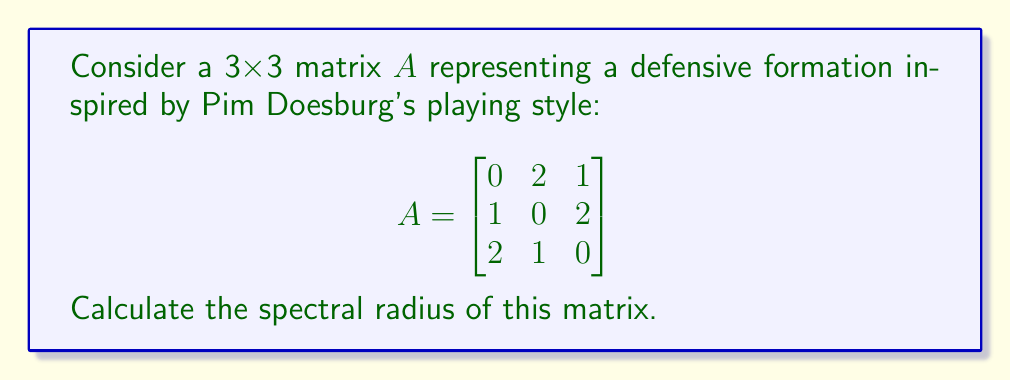Teach me how to tackle this problem. To find the spectral radius of matrix $A$, we need to follow these steps:

1) Calculate the eigenvalues of $A$:
   - Find the characteristic polynomial: $det(A - \lambda I) = 0$
   - Solve for $\lambda$

2) The spectral radius is the maximum absolute value of the eigenvalues.

Step 1: Calculate eigenvalues

a) Set up the characteristic equation:
   $$det(A - \lambda I) = \begin{vmatrix}
   -\lambda & 2 & 1 \\
   1 & -\lambda & 2 \\
   2 & 1 & -\lambda
   \end{vmatrix} = 0$$

b) Expand the determinant:
   $-\lambda^3 + 2\lambda - (2\lambda + 2\lambda + 1) = 0$
   $-\lambda^3 - 4\lambda - 1 = 0$

c) Solve this cubic equation. The solutions are:
   $\lambda_1 = -2$
   $\lambda_2 = 1 + i$
   $\lambda_3 = 1 - i$

Step 2: Find the spectral radius

The absolute values of the eigenvalues are:
$|\lambda_1| = 2$
$|\lambda_2| = |\lambda_3| = \sqrt{1^2 + 1^2} = \sqrt{2}$

The spectral radius is the maximum of these values, which is 2.
Answer: 2 